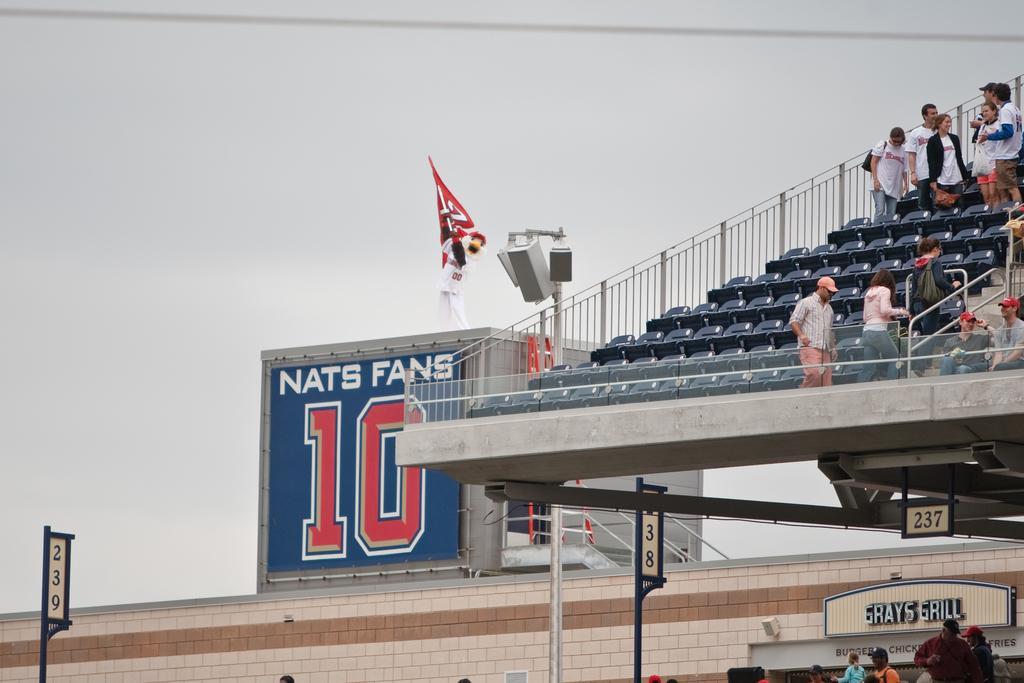Can you describe this image briefly? In the foreground I can see poles, fence, shed and a group of people in a stadium. In the background I can see the sky. This image is taken may be in a stadium. 